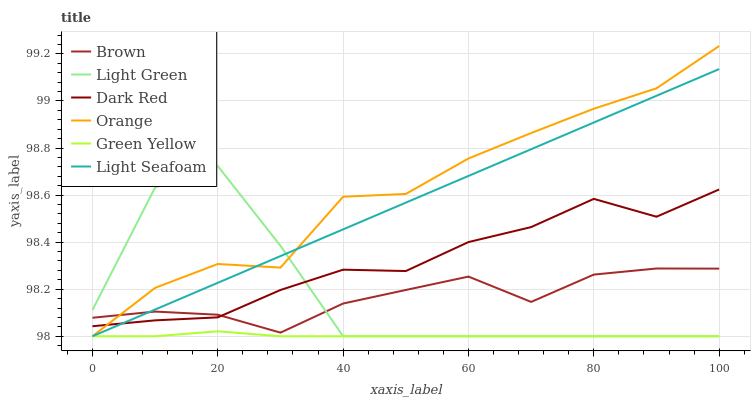Does Green Yellow have the minimum area under the curve?
Answer yes or no. Yes. Does Orange have the maximum area under the curve?
Answer yes or no. Yes. Does Light Seafoam have the minimum area under the curve?
Answer yes or no. No. Does Light Seafoam have the maximum area under the curve?
Answer yes or no. No. Is Light Seafoam the smoothest?
Answer yes or no. Yes. Is Light Green the roughest?
Answer yes or no. Yes. Is Dark Red the smoothest?
Answer yes or no. No. Is Dark Red the roughest?
Answer yes or no. No. Does Light Seafoam have the lowest value?
Answer yes or no. Yes. Does Dark Red have the lowest value?
Answer yes or no. No. Does Orange have the highest value?
Answer yes or no. Yes. Does Light Seafoam have the highest value?
Answer yes or no. No. Is Green Yellow less than Brown?
Answer yes or no. Yes. Is Dark Red greater than Green Yellow?
Answer yes or no. Yes. Does Green Yellow intersect Orange?
Answer yes or no. Yes. Is Green Yellow less than Orange?
Answer yes or no. No. Is Green Yellow greater than Orange?
Answer yes or no. No. Does Green Yellow intersect Brown?
Answer yes or no. No. 